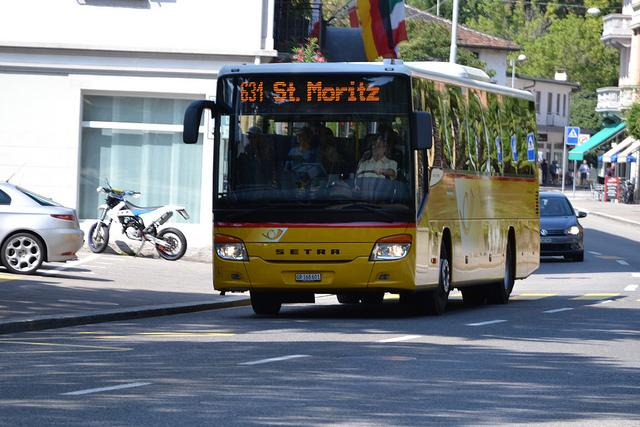What is the speed limit of school bus? Please explain your reasoning. 50mph. The question is not related to the image but is internet searchable. 